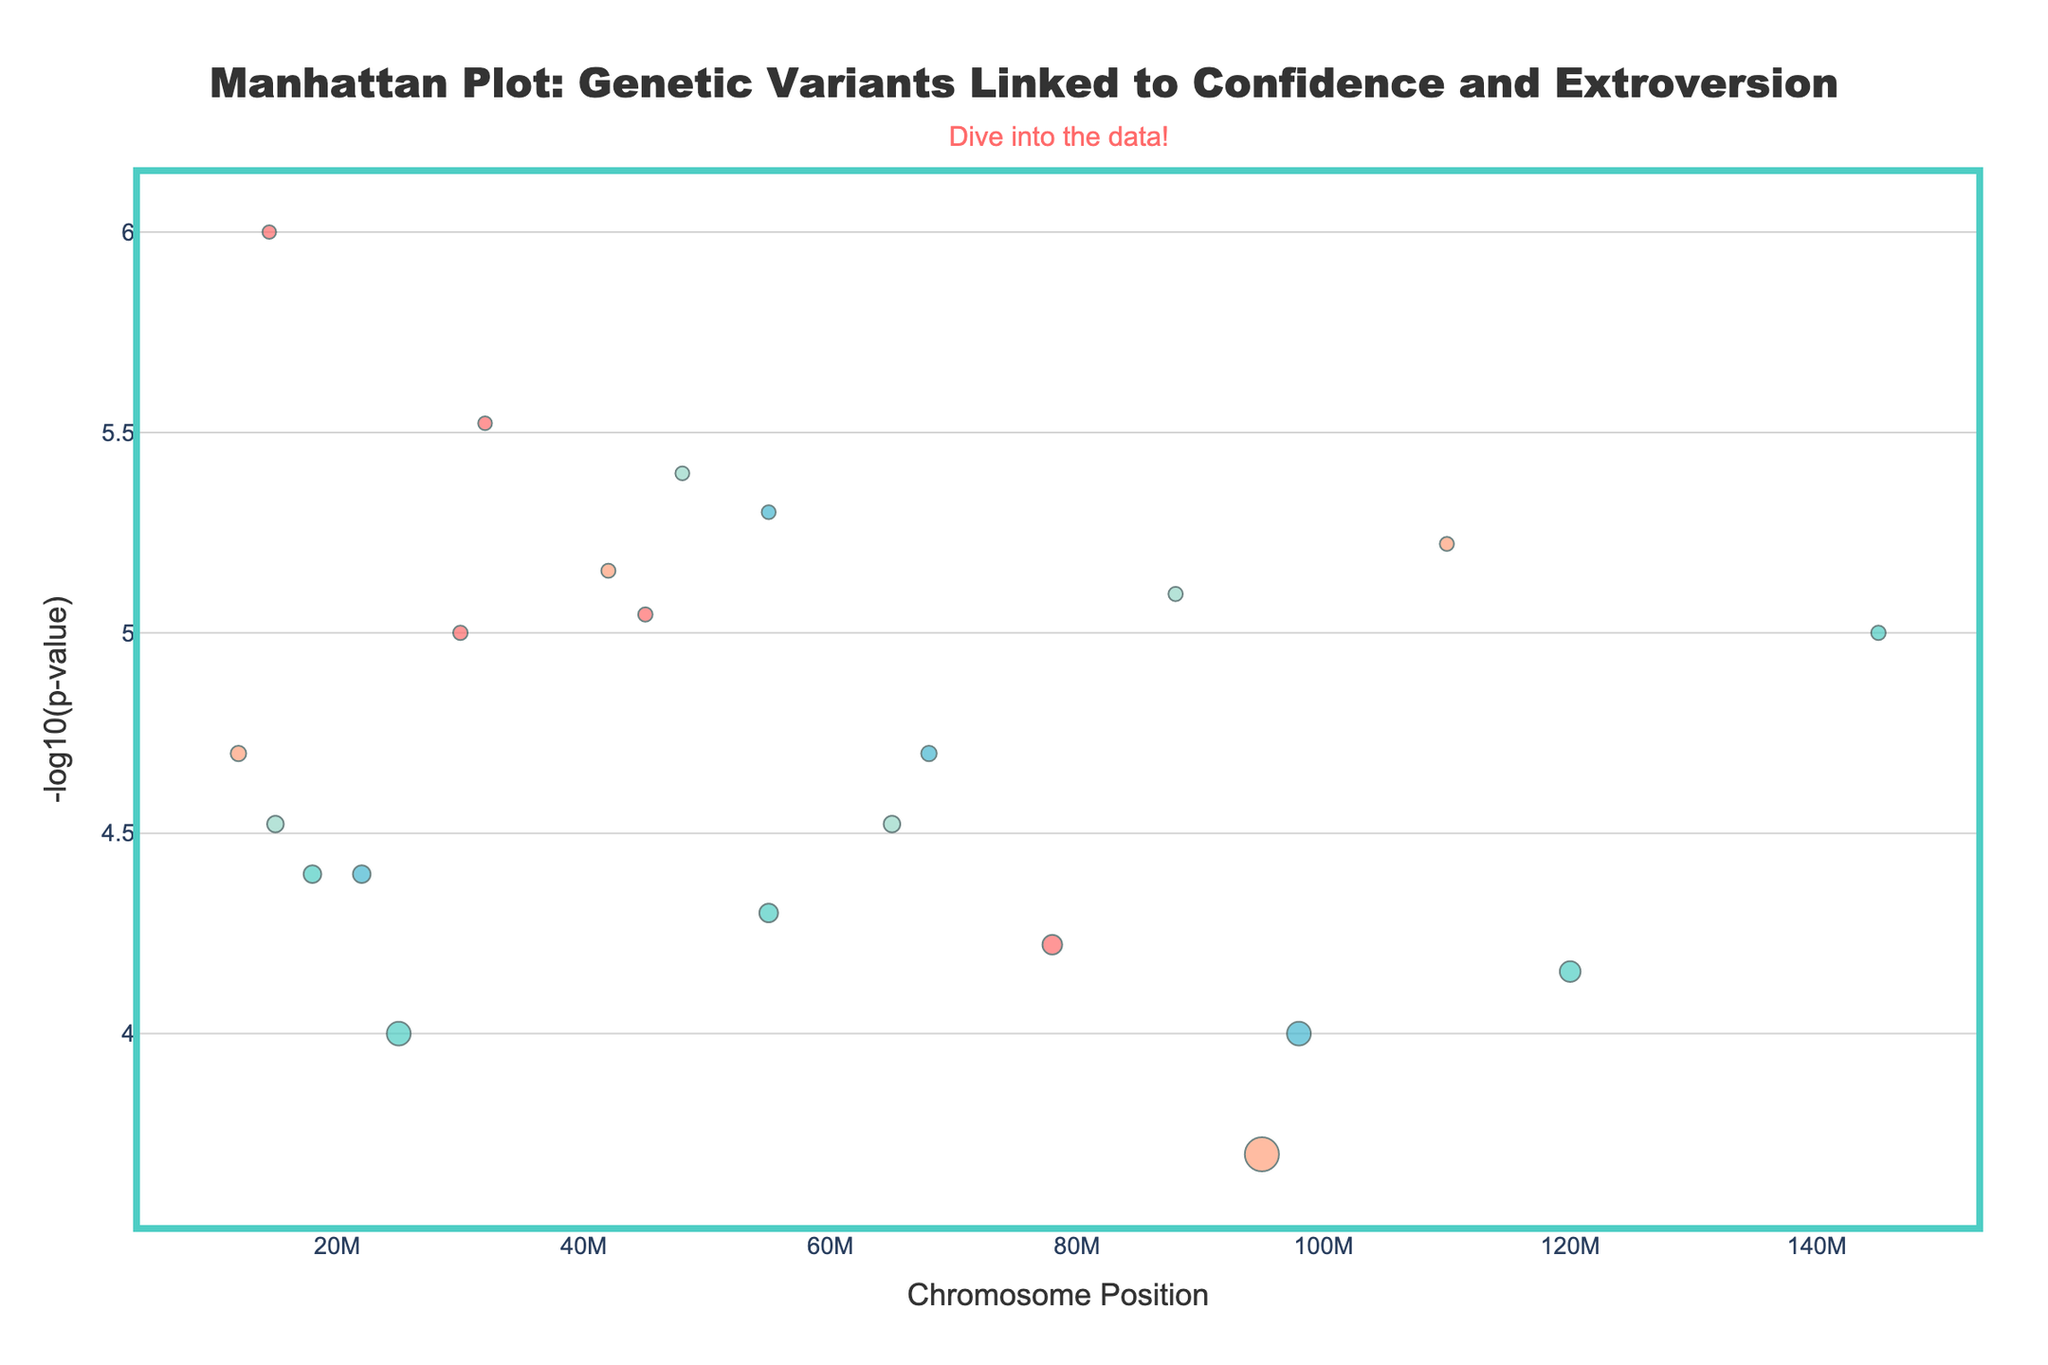What is the title of the Manhattan plot? The title of the plot is displayed at the top center of the figure. It reads "Manhattan Plot: Genetic Variants Linked to Confidence and Extroversion" in a bold font.
Answer: Manhattan Plot: Genetic Variants Linked to Confidence and Extroversion What do the colors of the data points represent in the plot? The colors of the data points represent different chromosomes. Each chromosome is shown in a distinct color to distinguish one from another.
Answer: Different chromosomes Which chromosome has the SNP with the smallest p-value? The p-values are represented as -log10(p-value) on the y-axis, where a higher value indicates a smaller p-value. Chromosome 1 has the SNP (rs4950) with the highest -log10(p-value) value, indicating the smallest p-value.
Answer: Chromosome 1 What trait is associated with the SNP rs25531? The hover text for each point in the plot displays the SNP and the associated trait. The SNP rs25531 is associated with the trait "Social adaptability".
Answer: Social adaptability How many chromosomes have significant SNPs (p-value < 0.0001)? To determine this, locate points on the plot with a -log10(p-value) greater than 4 (since -log10(0.0001) = 4). Count the number of distinct chromosomes represented by these points. The chromosomes are 1, 2, 4, 5, 6, 9, 13, 19, and 21.
Answer: 9 chromosomes What is the highest -log10(p-value) on the plot, and what trait does it represent? The highest -log10(p-value) corresponds to the peak point on the y-axis. The highest value is for the SNP rs4950, which is associated with the trait "Extroversion".
Answer: 6 and Extroversion Which SNP is associated with the trait "Leadership tendency", and what chromosome is it located on? Hover over the points or look for the trait "Leadership tendency" in the hover text. The SNP rs237887 is associated with "Leadership tendency" and is located on chromosome 8.
Answer: rs237887 on chromosome 8 Compare the -log10(p-value) of rs1051931 and rs4680. Which one is higher? Check the -log10(p-value) for each SNP by finding their respective points and reading the y-axis value. The -log10(p-value) for rs4680, associated with the trait "Cognitive flexibility", is higher than that for rs1051931, associated with "Charisma".
Answer: rs4680 What chromosome position has the highest number of associated SNPs? Examine the plot to see which chromosome (x-axis) has the densest cluster of points. Chromosome 1 appears to have multiple points closely packed together.
Answer: Chromosome 1 What are the -log10(p-value) and trait for SNP rs3800373? Hover over the point corresponding to SNP rs3800373 to read the -log10(p-value) and trait. The -log10(p-value) is around 4.1 and the trait is "Stress resilience".
Answer: 4.1 and Stress resilience 